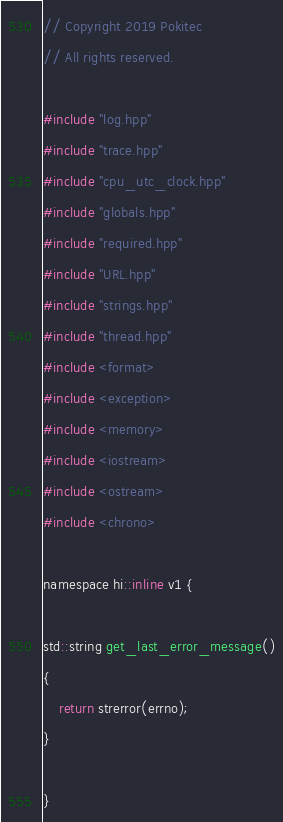Convert code to text. <code><loc_0><loc_0><loc_500><loc_500><_ObjectiveC_>// Copyright 2019 Pokitec
// All rights reserved.

#include "log.hpp"
#include "trace.hpp"
#include "cpu_utc_clock.hpp"
#include "globals.hpp"
#include "required.hpp"
#include "URL.hpp"
#include "strings.hpp"
#include "thread.hpp"
#include <format>
#include <exception>
#include <memory>
#include <iostream>
#include <ostream>
#include <chrono>

namespace hi::inline v1 {

std::string get_last_error_message()
{
    return strerror(errno);
}

}
</code> 